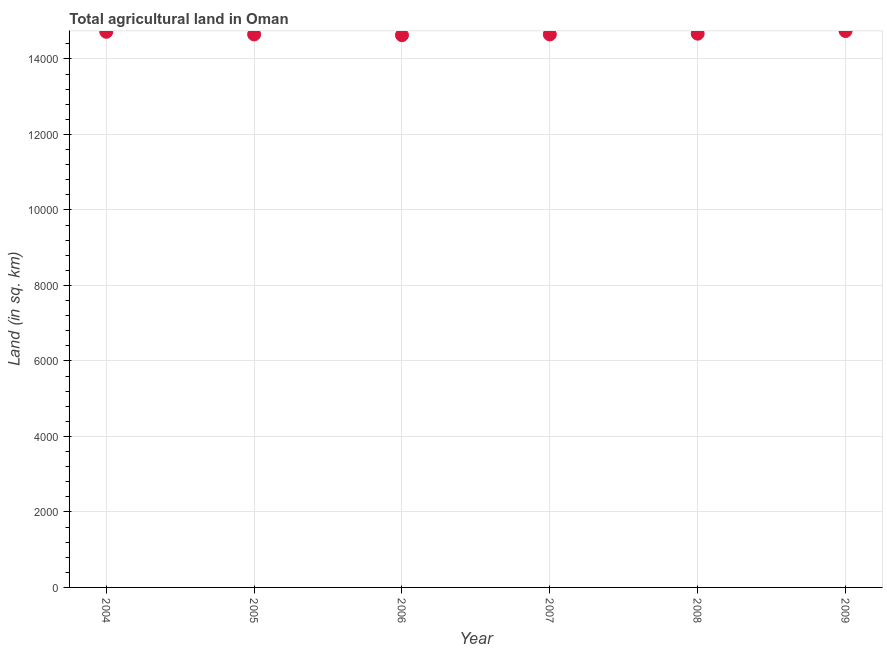What is the agricultural land in 2008?
Your answer should be very brief. 1.47e+04. Across all years, what is the maximum agricultural land?
Offer a very short reply. 1.47e+04. Across all years, what is the minimum agricultural land?
Ensure brevity in your answer.  1.46e+04. In which year was the agricultural land maximum?
Offer a very short reply. 2009. What is the sum of the agricultural land?
Make the answer very short. 8.81e+04. What is the difference between the agricultural land in 2006 and 2008?
Ensure brevity in your answer.  -40. What is the average agricultural land per year?
Provide a succinct answer. 1.47e+04. What is the median agricultural land?
Ensure brevity in your answer.  1.47e+04. In how many years, is the agricultural land greater than 10800 sq. km?
Ensure brevity in your answer.  6. What is the ratio of the agricultural land in 2005 to that in 2006?
Provide a succinct answer. 1. Is the agricultural land in 2005 less than that in 2008?
Give a very brief answer. Yes. Is the difference between the agricultural land in 2005 and 2008 greater than the difference between any two years?
Offer a terse response. No. What is the difference between the highest and the second highest agricultural land?
Provide a short and direct response. 20. Is the sum of the agricultural land in 2007 and 2009 greater than the maximum agricultural land across all years?
Provide a succinct answer. Yes. What is the difference between the highest and the lowest agricultural land?
Provide a succinct answer. 110. How many dotlines are there?
Your answer should be very brief. 1. What is the difference between two consecutive major ticks on the Y-axis?
Your answer should be very brief. 2000. What is the title of the graph?
Offer a very short reply. Total agricultural land in Oman. What is the label or title of the Y-axis?
Offer a terse response. Land (in sq. km). What is the Land (in sq. km) in 2004?
Provide a short and direct response. 1.47e+04. What is the Land (in sq. km) in 2005?
Provide a succinct answer. 1.46e+04. What is the Land (in sq. km) in 2006?
Your response must be concise. 1.46e+04. What is the Land (in sq. km) in 2007?
Provide a succinct answer. 1.46e+04. What is the Land (in sq. km) in 2008?
Your answer should be very brief. 1.47e+04. What is the Land (in sq. km) in 2009?
Ensure brevity in your answer.  1.47e+04. What is the difference between the Land (in sq. km) in 2005 and 2006?
Provide a short and direct response. 20. What is the difference between the Land (in sq. km) in 2005 and 2007?
Your answer should be very brief. 0. What is the difference between the Land (in sq. km) in 2005 and 2008?
Ensure brevity in your answer.  -20. What is the difference between the Land (in sq. km) in 2005 and 2009?
Ensure brevity in your answer.  -90. What is the difference between the Land (in sq. km) in 2006 and 2007?
Make the answer very short. -20. What is the difference between the Land (in sq. km) in 2006 and 2009?
Give a very brief answer. -110. What is the difference between the Land (in sq. km) in 2007 and 2009?
Offer a terse response. -90. What is the difference between the Land (in sq. km) in 2008 and 2009?
Offer a very short reply. -70. What is the ratio of the Land (in sq. km) in 2005 to that in 2007?
Your answer should be compact. 1. What is the ratio of the Land (in sq. km) in 2005 to that in 2008?
Offer a terse response. 1. What is the ratio of the Land (in sq. km) in 2005 to that in 2009?
Offer a terse response. 0.99. What is the ratio of the Land (in sq. km) in 2006 to that in 2007?
Give a very brief answer. 1. What is the ratio of the Land (in sq. km) in 2006 to that in 2008?
Keep it short and to the point. 1. What is the ratio of the Land (in sq. km) in 2007 to that in 2008?
Offer a very short reply. 1. What is the ratio of the Land (in sq. km) in 2007 to that in 2009?
Make the answer very short. 0.99. 